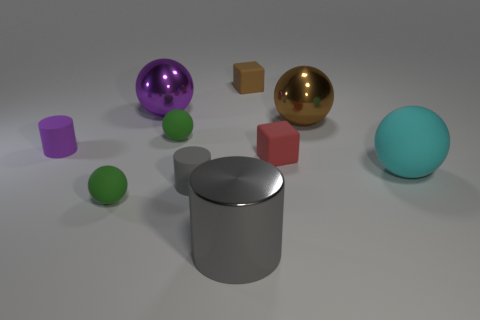Subtract all matte balls. How many balls are left? 2 Subtract all purple cylinders. How many cylinders are left? 2 Subtract 2 balls. How many balls are left? 3 Subtract all cylinders. How many objects are left? 7 Subtract all green cylinders. How many red blocks are left? 1 Subtract all big gray blocks. Subtract all large cylinders. How many objects are left? 9 Add 5 small red rubber objects. How many small red rubber objects are left? 6 Add 3 small gray matte objects. How many small gray matte objects exist? 4 Subtract 0 brown cylinders. How many objects are left? 10 Subtract all gray cubes. Subtract all yellow cylinders. How many cubes are left? 2 